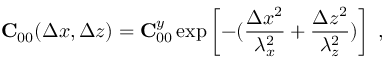Convert formula to latex. <formula><loc_0><loc_0><loc_500><loc_500>{ C } _ { 0 0 } ( \Delta x , \Delta z ) = { C } _ { 0 0 } ^ { y } \exp \left [ - ( \frac { \Delta x ^ { 2 } } { \lambda _ { x } ^ { 2 } } + \frac { \Delta z ^ { 2 } } { \lambda _ { z } ^ { 2 } } ) \right ] ,</formula> 